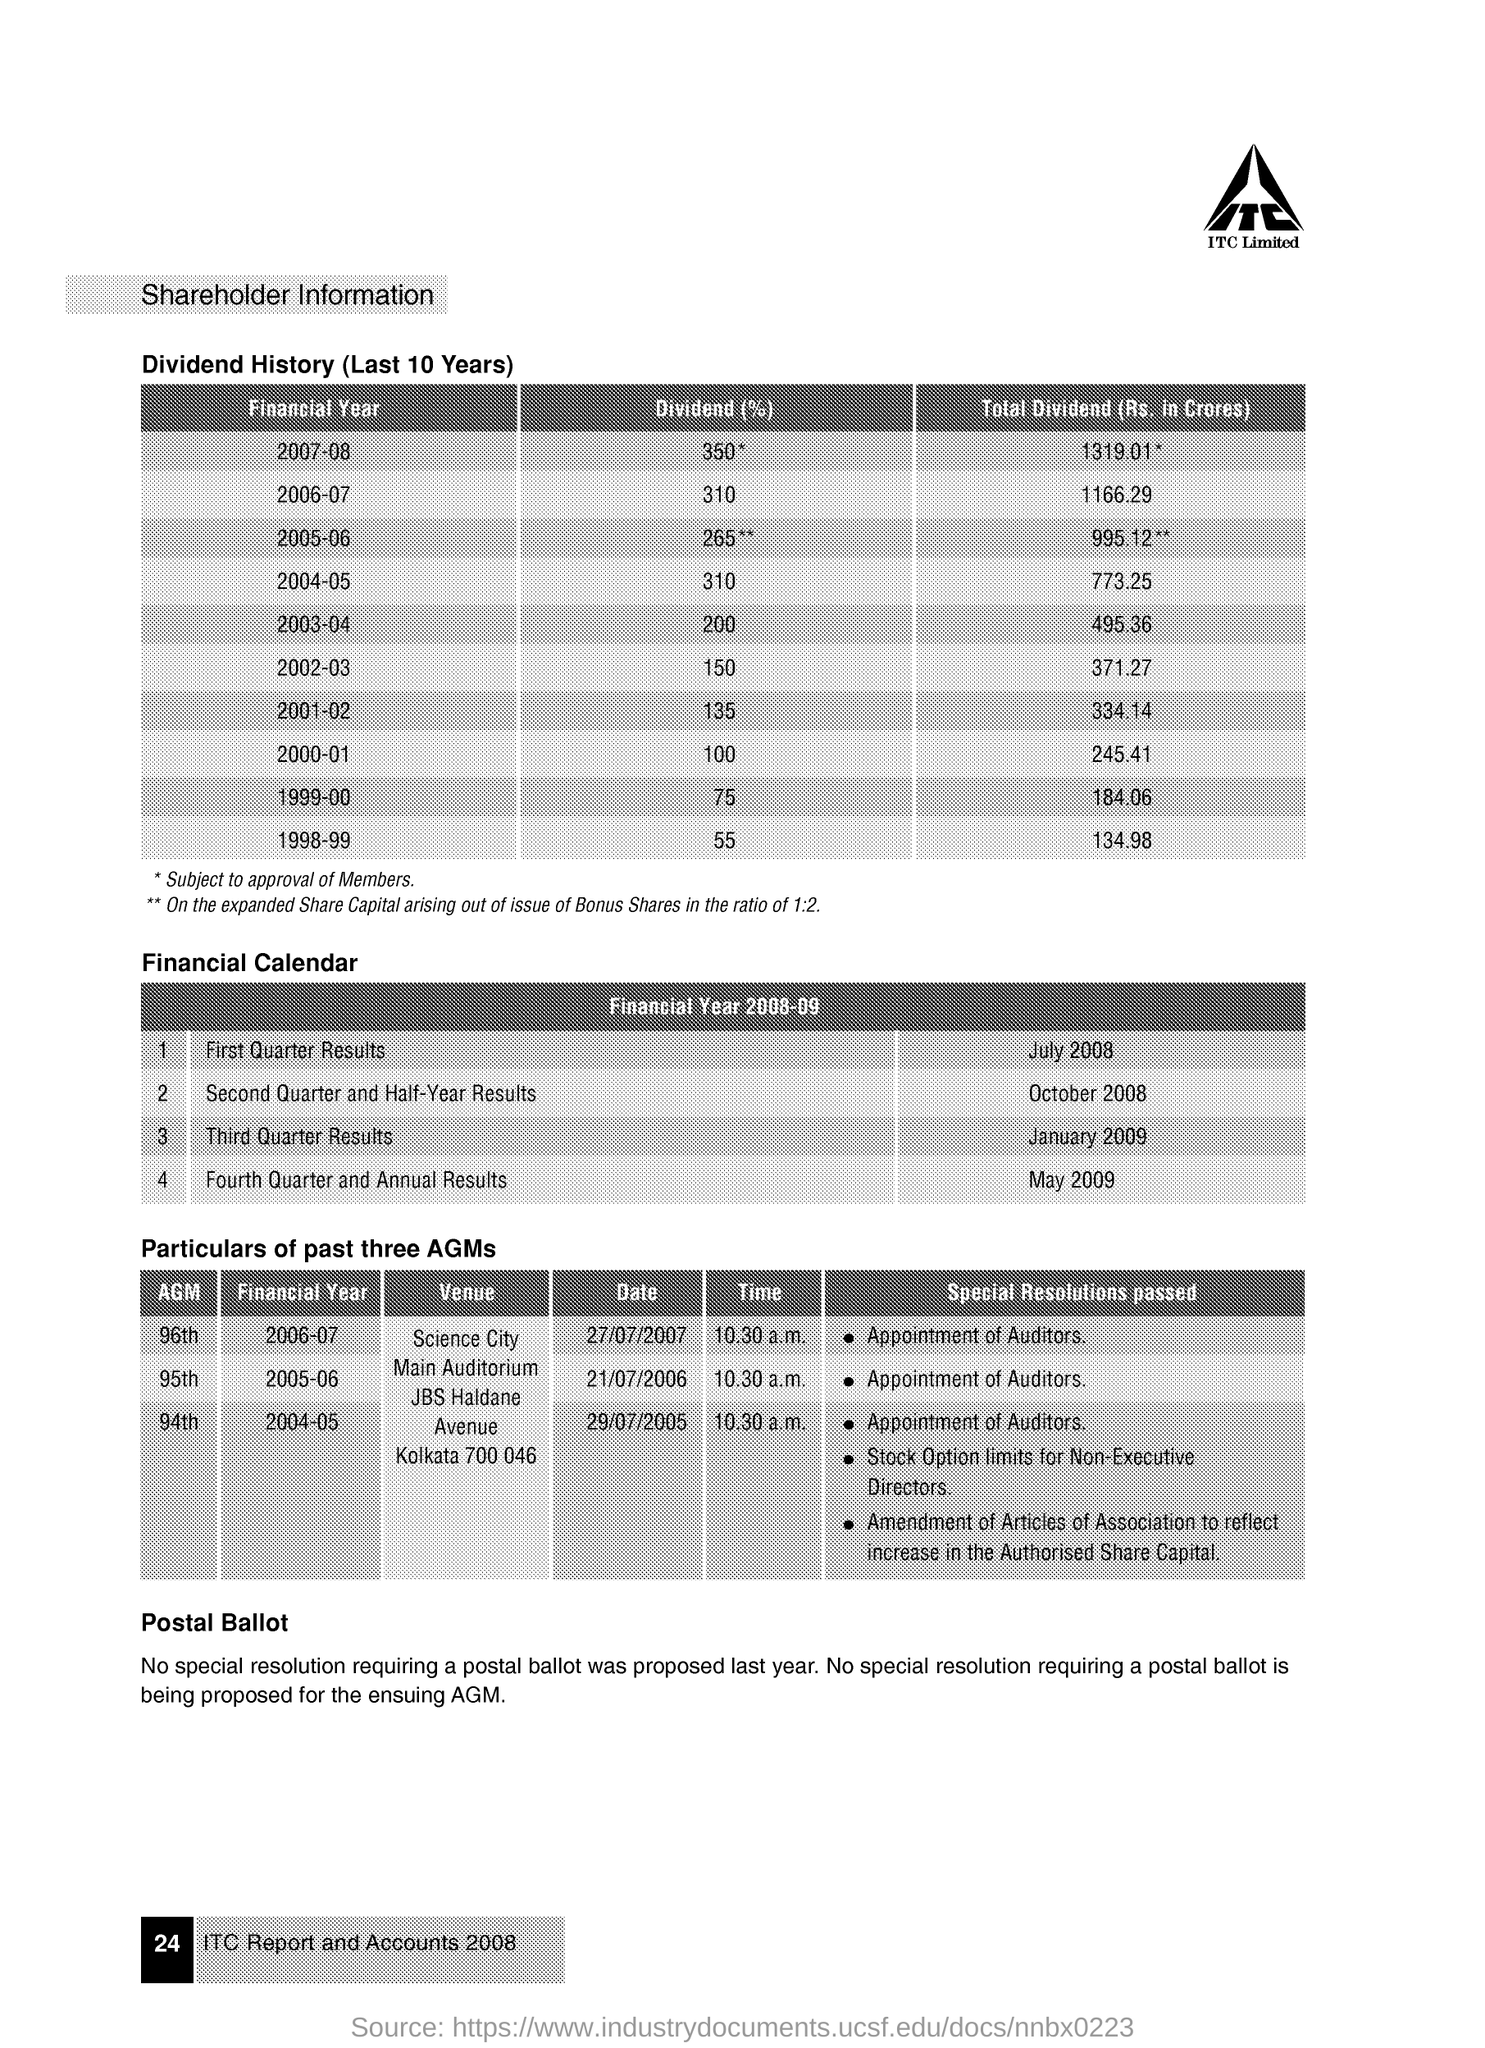What is the total dividend (rs in crores ) for the financial year 2007-08
Provide a succinct answer. 1319.01. What is the dividend (%) for the financial year 2002-03
Provide a succinct answer. 150. What is the total dividend (rs in crores ) for the financial year 1998-99
Provide a succinct answer. 134.98. What is the dividend (%) for the financial year 2000-01
Make the answer very short. 100. When was the first quarter results released ?
Your answer should be compact. July 2008. What is the date of 96th agm for the financial year 2006-07?
Provide a succinct answer. 27/07/2007. What are the special resolutions passed for the 96th agm for the financial year 2006-07
Your response must be concise. Appointment of Auditors. What is the total dividend (rs in crores ) for the financial year 2003-04
Your answer should be very brief. 495.36. When was the fourth quarter and annual results were released
Offer a terse response. May 2009. 